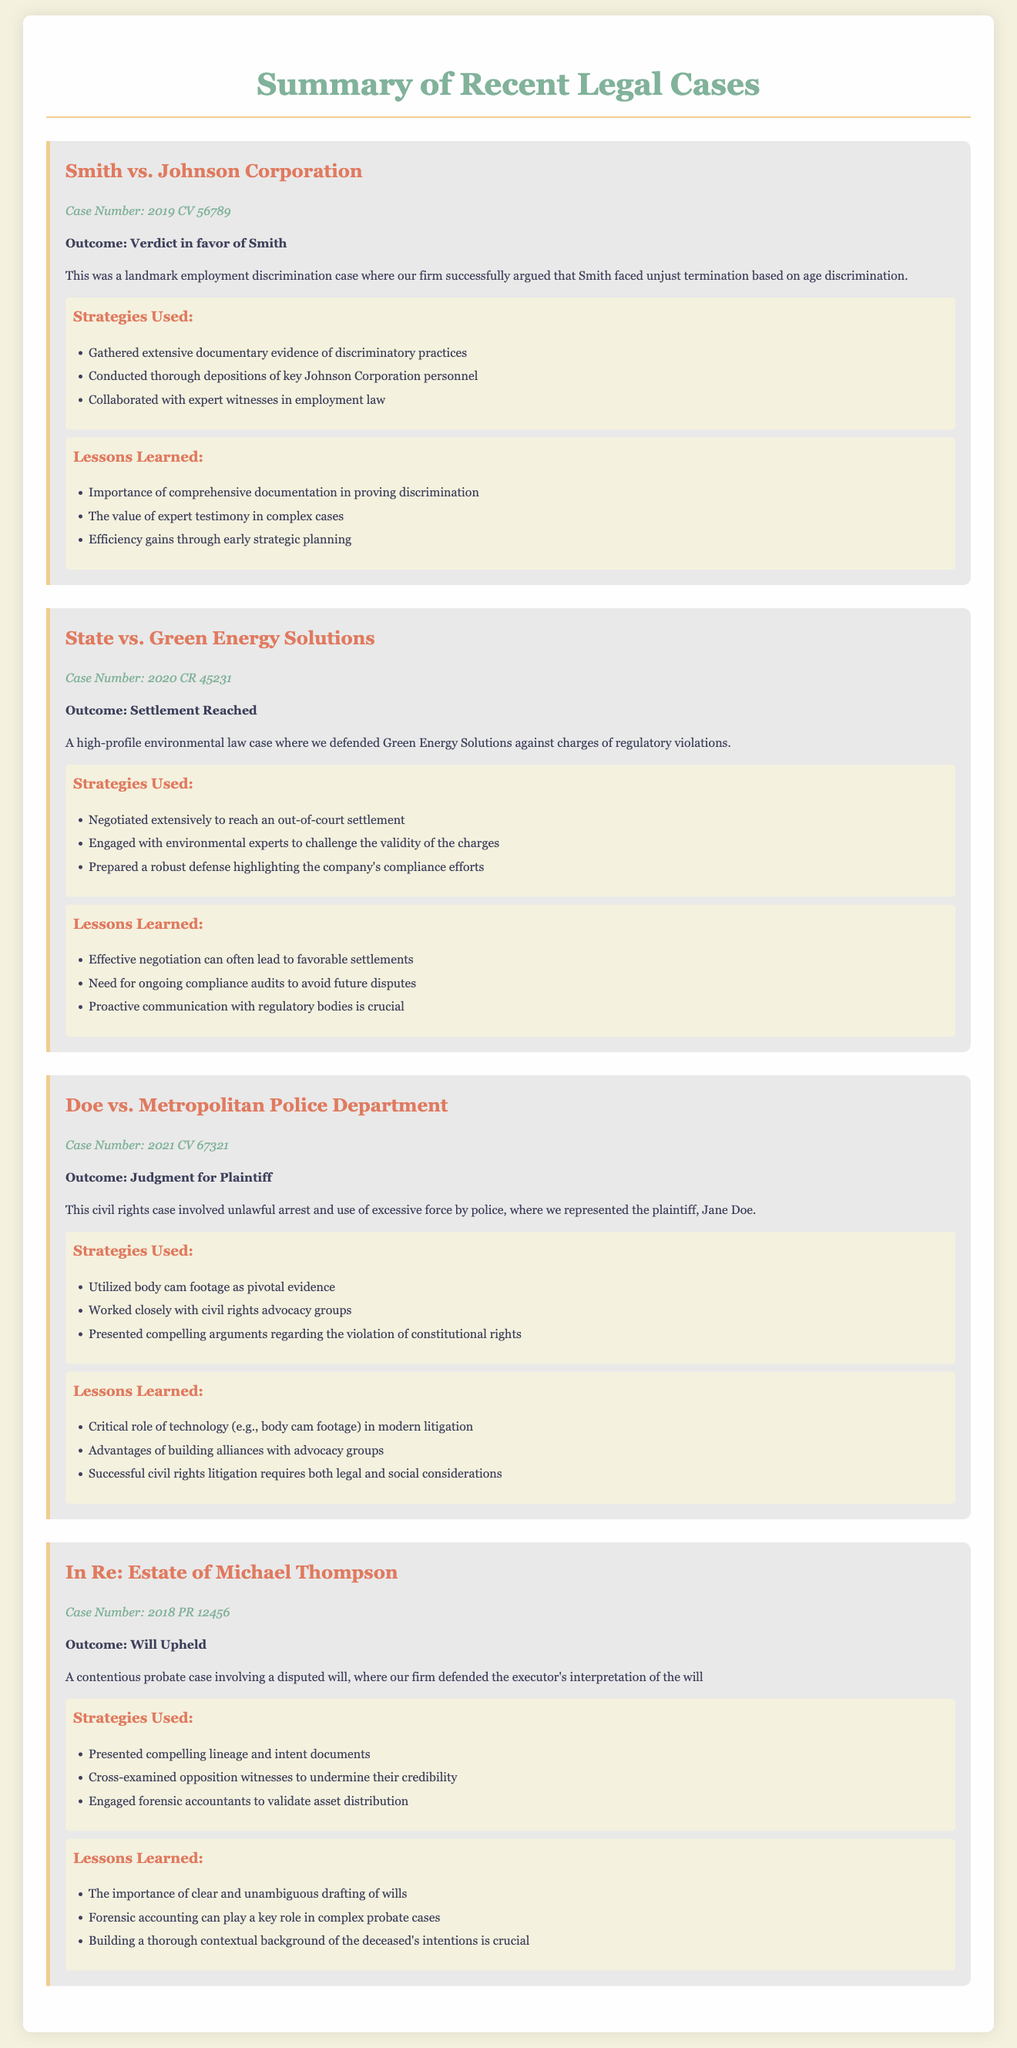What was the outcome of Smith vs. Johnson Corporation? The outcome is stated in the document for this case, which is a verdict in favor of Smith.
Answer: Verdict in favor of Smith What strategies were used in the State vs. Green Energy Solutions case? The document lists the strategies used in this case, including negotiating extensively and engaging with environmental experts.
Answer: Negotiated extensively to reach an out-of-court settlement Who represented the plaintiff in Doe vs. Metropolitan Police Department? The document specifies that Jane Doe was the plaintiff represented in this case.
Answer: Jane Doe What lesson was learned from the In Re: Estate of Michael Thompson case? The document mentions multiple lessons; one of them emphasizes the importance of clear drafting of wills.
Answer: The importance of clear and unambiguous drafting of wills What was the case number for Doe vs. Metropolitan Police Department? The case number for this specific case is detailed in the document.
Answer: 2021 CV 67321 How many key strategies were listed for the Smith vs. Johnson Corporation case? The document provides a list of strategies, which can be counted directly from the text.
Answer: Three What type of case is State vs. Green Energy Solutions? The document classifies this case under environmental law.
Answer: Environmental law case What was the outcome in the In Re: Estate of Michael Thompson case? The outcome is explicitly stated in the document for this probate case.
Answer: Will Upheld 